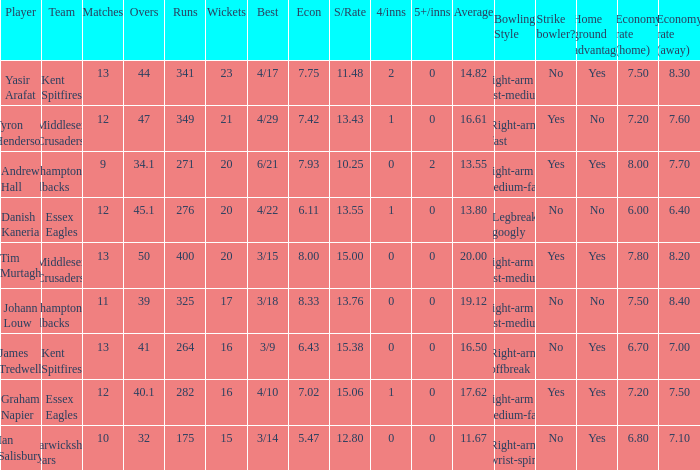Name the matches for wickets 17 11.0. 